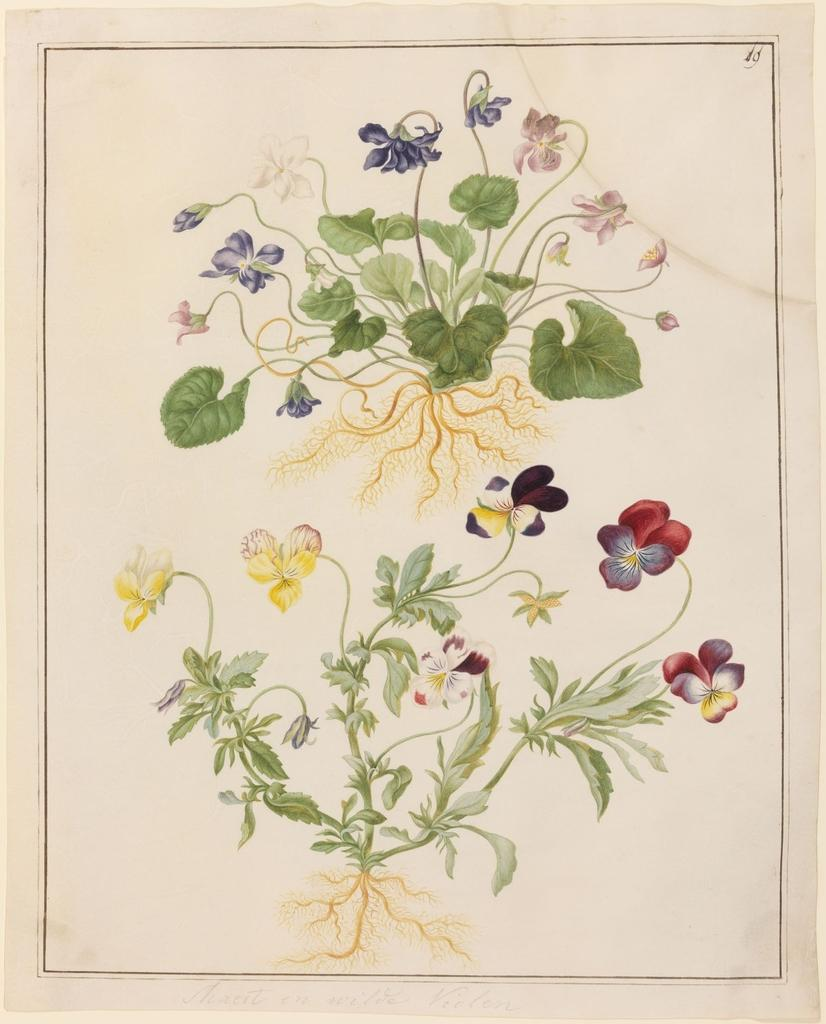What is located in the foreground of the picture? There is a poster in the foreground of the picture. What is depicted on the poster? The poster contains flowers and plants. How many quivers can be seen hanging on the wall in the image? There are no quivers present in the image; it features a poster with flowers and plants. Are there any goats or lizards visible in the image? No, there are no goats or lizards present in the image. 